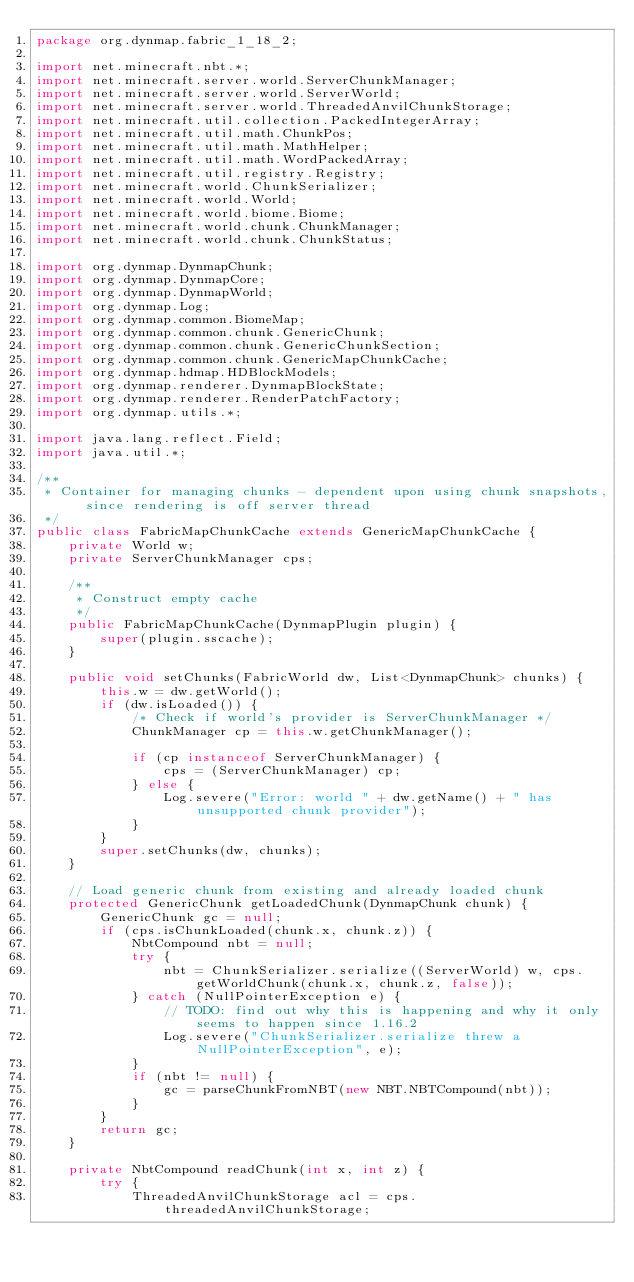Convert code to text. <code><loc_0><loc_0><loc_500><loc_500><_Java_>package org.dynmap.fabric_1_18_2;

import net.minecraft.nbt.*;
import net.minecraft.server.world.ServerChunkManager;
import net.minecraft.server.world.ServerWorld;
import net.minecraft.server.world.ThreadedAnvilChunkStorage;
import net.minecraft.util.collection.PackedIntegerArray;
import net.minecraft.util.math.ChunkPos;
import net.minecraft.util.math.MathHelper;
import net.minecraft.util.math.WordPackedArray;
import net.minecraft.util.registry.Registry;
import net.minecraft.world.ChunkSerializer;
import net.minecraft.world.World;
import net.minecraft.world.biome.Biome;
import net.minecraft.world.chunk.ChunkManager;
import net.minecraft.world.chunk.ChunkStatus;

import org.dynmap.DynmapChunk;
import org.dynmap.DynmapCore;
import org.dynmap.DynmapWorld;
import org.dynmap.Log;
import org.dynmap.common.BiomeMap;
import org.dynmap.common.chunk.GenericChunk;
import org.dynmap.common.chunk.GenericChunkSection;
import org.dynmap.common.chunk.GenericMapChunkCache;
import org.dynmap.hdmap.HDBlockModels;
import org.dynmap.renderer.DynmapBlockState;
import org.dynmap.renderer.RenderPatchFactory;
import org.dynmap.utils.*;

import java.lang.reflect.Field;
import java.util.*;

/**
 * Container for managing chunks - dependent upon using chunk snapshots, since rendering is off server thread
 */
public class FabricMapChunkCache extends GenericMapChunkCache {
    private World w;
    private ServerChunkManager cps;

    /**
     * Construct empty cache
     */
    public FabricMapChunkCache(DynmapPlugin plugin) {
    	super(plugin.sscache);
    }

    public void setChunks(FabricWorld dw, List<DynmapChunk> chunks) {
        this.w = dw.getWorld();
        if (dw.isLoaded()) {
            /* Check if world's provider is ServerChunkManager */
            ChunkManager cp = this.w.getChunkManager();

            if (cp instanceof ServerChunkManager) {
                cps = (ServerChunkManager) cp;
            } else {
                Log.severe("Error: world " + dw.getName() + " has unsupported chunk provider");
            }
        } 
        super.setChunks(dw, chunks);
    }

	// Load generic chunk from existing and already loaded chunk
	protected GenericChunk getLoadedChunk(DynmapChunk chunk) {
		GenericChunk gc = null;
        if (cps.isChunkLoaded(chunk.x, chunk.z)) {
            NbtCompound nbt = null;
            try {
                nbt = ChunkSerializer.serialize((ServerWorld) w, cps.getWorldChunk(chunk.x, chunk.z, false));
            } catch (NullPointerException e) {
                // TODO: find out why this is happening and why it only seems to happen since 1.16.2
                Log.severe("ChunkSerializer.serialize threw a NullPointerException", e);
            }
            if (nbt != null) {
            	gc = parseChunkFromNBT(new NBT.NBTCompound(nbt));
            }
		}
		return gc;
	}

    private NbtCompound readChunk(int x, int z) {
        try {
            ThreadedAnvilChunkStorage acl = cps.threadedAnvilChunkStorage;
</code> 